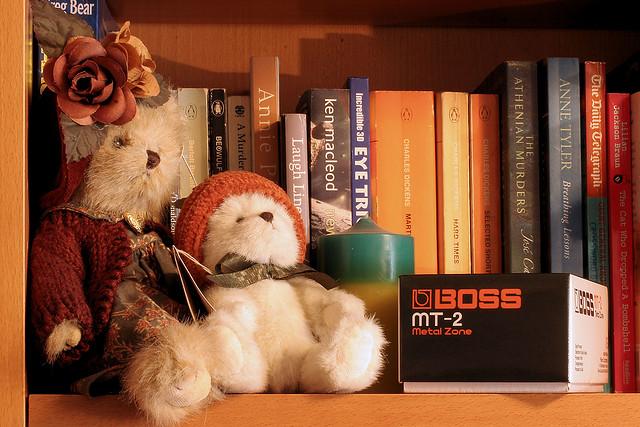What human body part is in the title of the blue book behind the candle?
Short answer required. Eye. What is behind the bears?
Concise answer only. Books. How many stuffed animals are there?
Give a very brief answer. 2. 